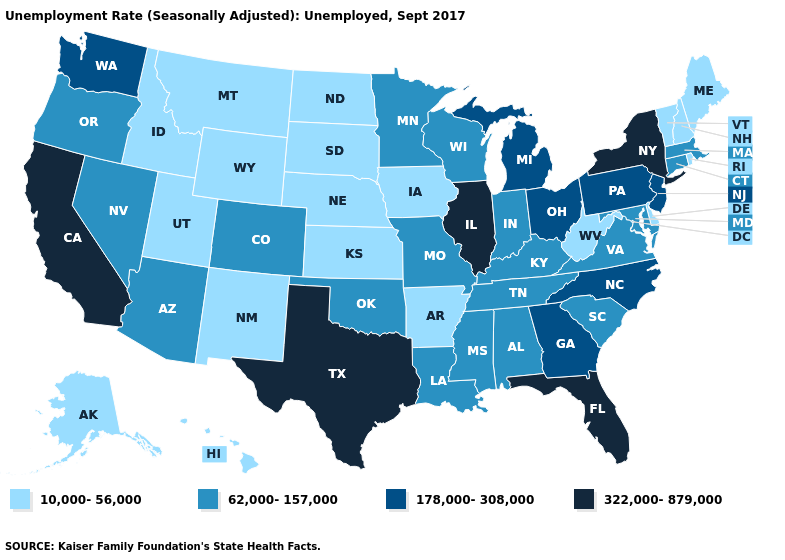Is the legend a continuous bar?
Give a very brief answer. No. Name the states that have a value in the range 322,000-879,000?
Quick response, please. California, Florida, Illinois, New York, Texas. What is the value of South Dakota?
Keep it brief. 10,000-56,000. Does Virginia have a lower value than Maine?
Short answer required. No. What is the lowest value in states that border Louisiana?
Quick response, please. 10,000-56,000. Which states have the lowest value in the Northeast?
Quick response, please. Maine, New Hampshire, Rhode Island, Vermont. What is the highest value in states that border New Jersey?
Write a very short answer. 322,000-879,000. What is the value of Michigan?
Be succinct. 178,000-308,000. What is the value of Connecticut?
Concise answer only. 62,000-157,000. Name the states that have a value in the range 178,000-308,000?
Write a very short answer. Georgia, Michigan, New Jersey, North Carolina, Ohio, Pennsylvania, Washington. Does California have the highest value in the West?
Concise answer only. Yes. Name the states that have a value in the range 322,000-879,000?
Give a very brief answer. California, Florida, Illinois, New York, Texas. Among the states that border Maryland , which have the highest value?
Quick response, please. Pennsylvania. Name the states that have a value in the range 322,000-879,000?
Short answer required. California, Florida, Illinois, New York, Texas. How many symbols are there in the legend?
Give a very brief answer. 4. 